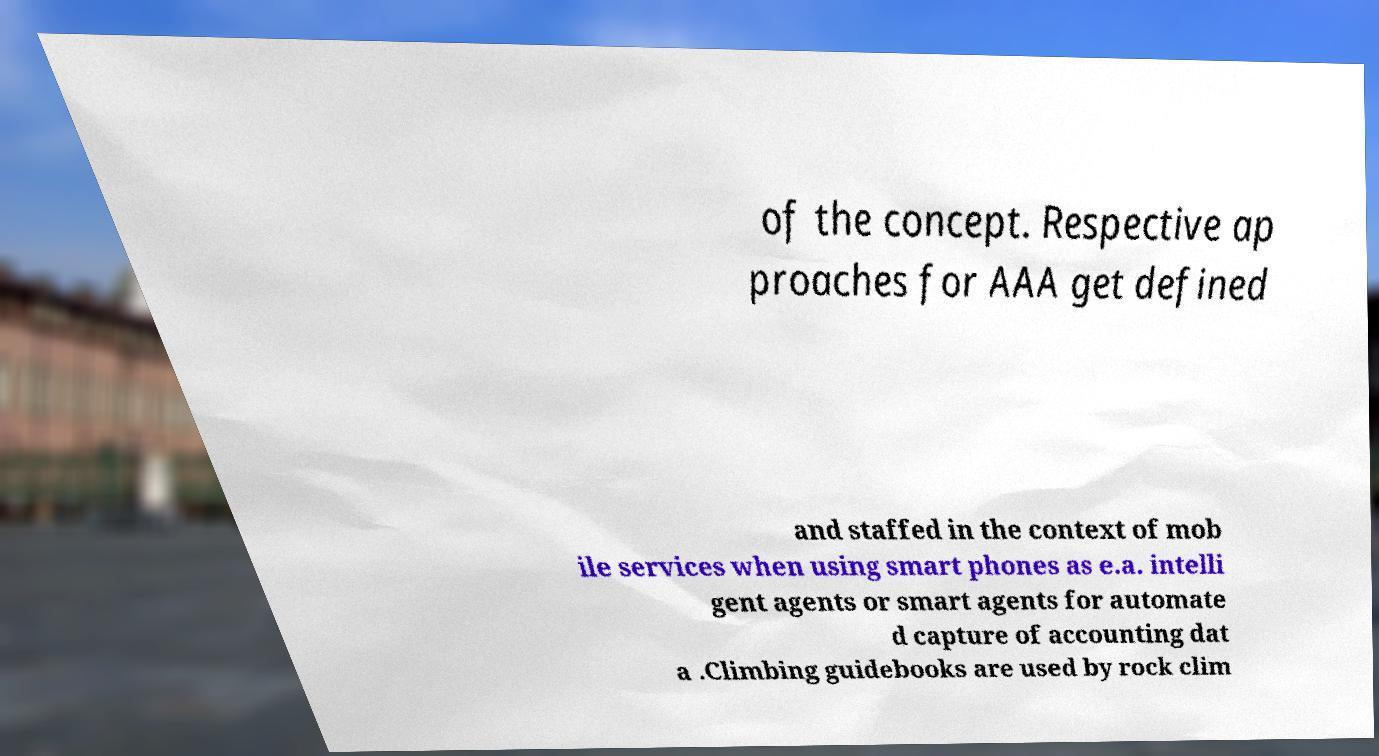What messages or text are displayed in this image? I need them in a readable, typed format. of the concept. Respective ap proaches for AAA get defined and staffed in the context of mob ile services when using smart phones as e.a. intelli gent agents or smart agents for automate d capture of accounting dat a .Climbing guidebooks are used by rock clim 